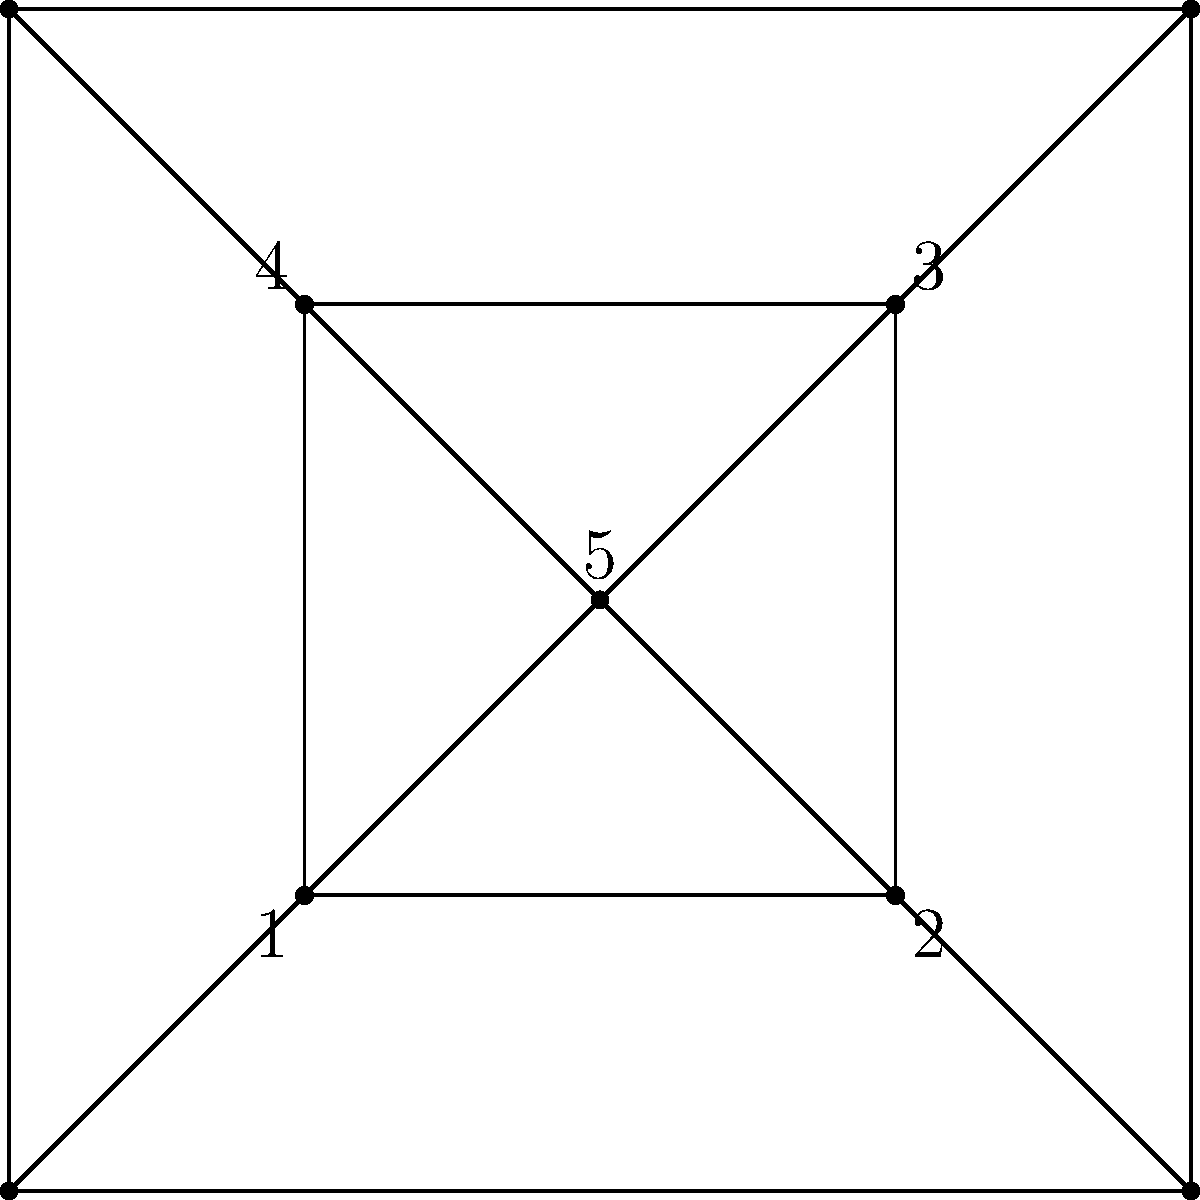In this geometric pattern inspired by the Concrete Art movement, popular among Brazilian artists like Lygia Clark and Hélio Oiticica, a square is divided into four equal parts by its diagonals. A smaller square is inscribed within, creating five distinct regions labeled 1 to 5. If the sum of the measures of angles in region 5 is 360°, what is the measure of each angle in region 5? Let's approach this step-by-step:

1) First, recall that the sum of angles in a quadrilateral is always 360°. This is why the sum of angles in region 5 is given as 360°.

2) Due to the symmetry of the figure, we can deduce that all four angles in region 5 are equal. Let's call the measure of each of these angles $x$.

3) Since there are four equal angles in region 5, and their sum is 360°, we can set up the equation:

   $4x = 360°$

4) Solving for $x$:
   
   $x = 360° ÷ 4 = 90°$

5) To verify, we can consider the properties of the figure:
   - The large square is divided into four equal parts by its diagonals.
   - The diagonals of a square intersect at right angles (90°).
   - The smaller inscribed square is rotated 45° relative to the larger square.

   These properties confirm that each angle in region 5 should indeed be 90°.
Answer: 90° 